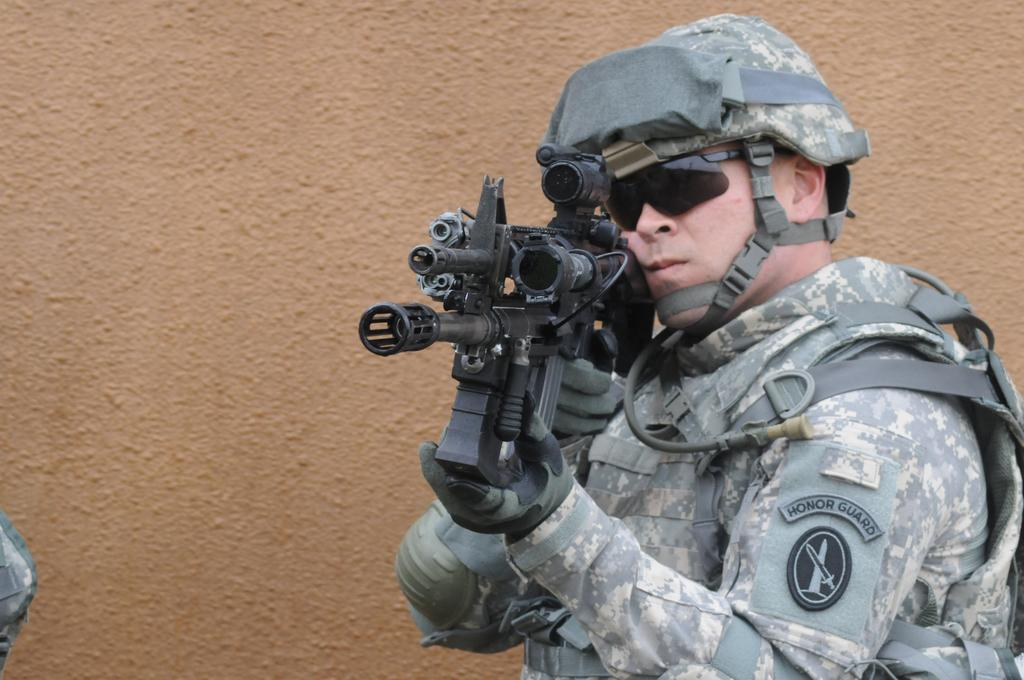What is the main subject in the foreground of the image? There is a person in the foreground of the image. What is the person doing in the image? The person is standing in the image. What object is the person holding in the image? The person is holding a gun in the image. What can be seen in the background of the image? There is a wall in the background of the image. What type of amusement can be heard ringing in the background of the image? There is no amusement or bells present in the image; it only features a person standing with a gun and a wall in the background. 